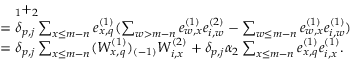<formula> <loc_0><loc_0><loc_500><loc_500>\begin{array} { r l } & { \quad _ { 1 } + _ { 2 } } \\ & { = \delta _ { p , j } \sum _ { x \leq m - n } e _ { x , q } ^ { ( 1 ) } ( \sum _ { w > m - n } e _ { w , x } ^ { ( 1 ) } e _ { i , w } ^ { ( 2 ) } - \sum _ { w \leq m - n } e _ { w , x } ^ { ( 1 ) } e _ { i , w } ^ { ( 1 ) } ) } \\ & { = \delta _ { p , j } \sum _ { x \leq m - n } ( W _ { x , q } ^ { ( 1 ) } ) _ { ( - 1 ) } W _ { i , x } ^ { ( 2 ) } + \delta _ { p , j } \alpha _ { 2 } \sum _ { x \leq m - n } e _ { x , q } ^ { ( 1 ) } e _ { i , x } ^ { ( 1 ) } . } \end{array}</formula> 